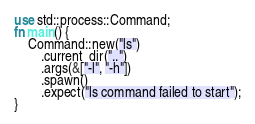Convert code to text. <code><loc_0><loc_0><loc_500><loc_500><_Rust_>use std::process::Command;
fn main() {
    Command::new("ls")
        .current_dir("..")
        .args(&["-l", "-h"])
        .spawn()
        .expect("ls command failed to start");
}
</code> 